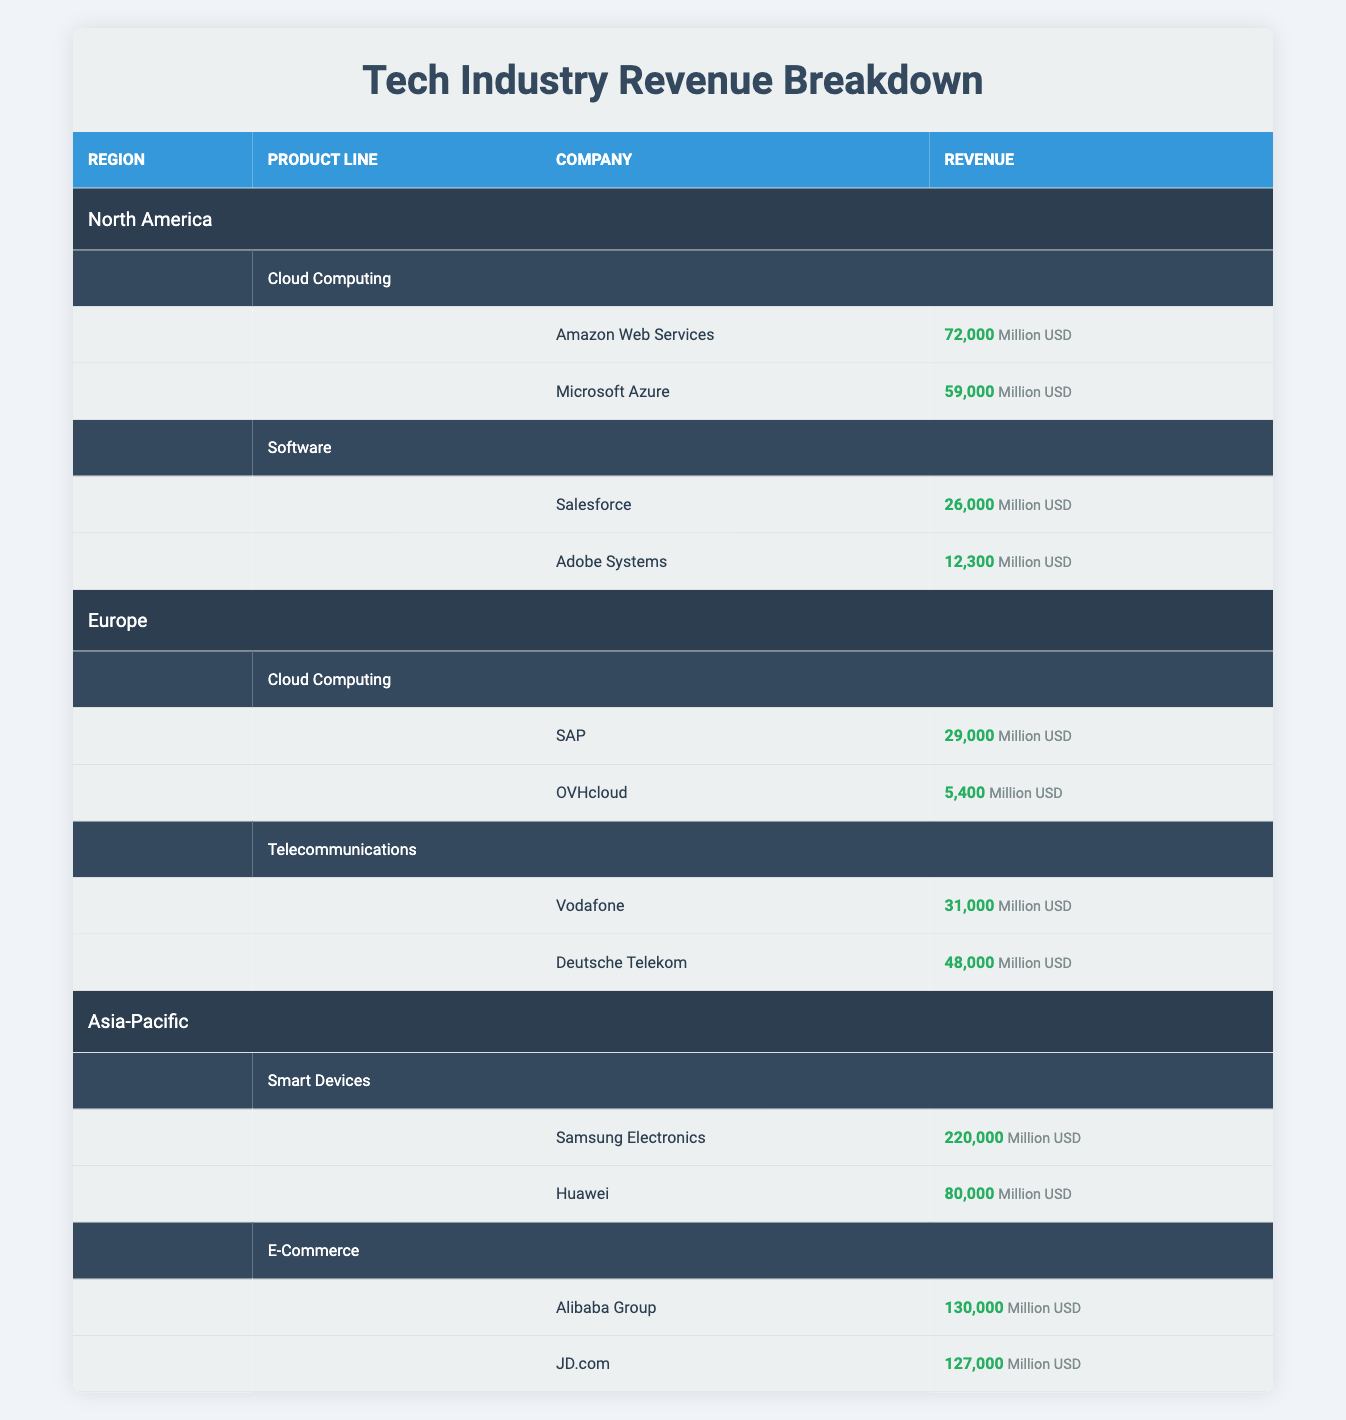What is the total revenue for Cloud Computing in North America? The Cloud Computing revenue in North America comes from two companies: Amazon Web Services with 72,000 million USD and Microsoft Azure with 59,000 million USD. Summing these gives: 72,000 + 59,000 = 131,000 million USD.
Answer: 131,000 million USD Which region has the highest revenue for Smart Devices? The Smart Devices revenue comes from Samsung Electronics with 220,000 million USD and Huawei with 80,000 million USD, both located in the Asia-Pacific region. Since this is the only region with Smart Devices, it has the highest revenue of 220,000 million USD.
Answer: Asia-Pacific Is the revenue from Deutsche Telekom greater than that from SAP? Deutsche Telekom has a revenue of 48,000 million USD while SAP's revenue is 29,000 million USD. Since 48,000 is greater than 29,000, the statement is true.
Answer: Yes What is the combined revenue from Telecommunications in Europe? The revenue in the Telecommunications product line in Europe comes from two companies: Vodafone with 31,000 million USD and Deutsche Telekom with 48,000 million USD. Adding these amounts gives: 31,000 + 48,000 = 79,000 million USD.
Answer: 79,000 million USD Is there a company that generates more than 100,000 million USD in revenue in the table? The companies listed do not exceed 100,000 million USD in revenue. The highest revenue from Samsung Electronics is 220,000 million USD, which is the only figure above the threshold. Thus, the statement is false.
Answer: Yes What is the revenue difference between the Cloud Computing products in North America and Europe? The total revenue for Cloud Computing in North America is 131,000 million USD (from earlier calculation), while in Europe, it is 29,000 million USD from SAP and 5,400 million USD from OVHcloud, totaling 34,400 million USD. The difference is calculated as: 131,000 - 34,400 = 96,600 million USD.
Answer: 96,600 million USD Which product line has the highest total revenue in the Asia-Pacific region? In Asia-Pacific, the E-Commerce line has revenues of 130,000 million USD (Alibaba Group) and 127,000 million USD (JD.com), totaling 257,000 million USD. The Smart Devices line has 220,000 million USD. Thus, E-Commerce has the highest revenue.
Answer: E-Commerce List all companies generating less than 30,000 million USD in revenue. In the table, the companies with revenues less than 30,000 million USD are OVHcloud with 5,400 million USD and Adobe Systems with 12,300 million USD.
Answer: OVHcloud, Adobe Systems 